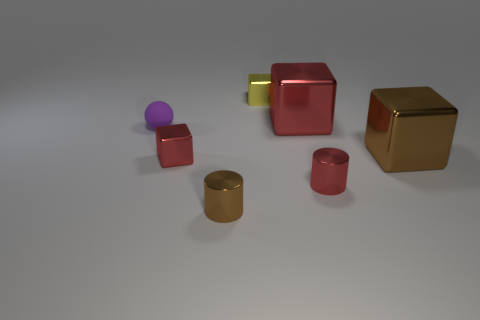Is there anything else that has the same material as the tiny purple ball?
Your answer should be compact. No. There is a red thing to the left of the yellow object; is it the same shape as the small matte thing?
Your answer should be very brief. No. There is a brown metallic thing in front of the brown block on the right side of the red metal cube that is behind the purple ball; what is its shape?
Give a very brief answer. Cylinder. The purple rubber ball is what size?
Make the answer very short. Small. The other tiny cylinder that is the same material as the red cylinder is what color?
Offer a terse response. Brown. How many brown cylinders are made of the same material as the small red cube?
Offer a very short reply. 1. Does the rubber thing have the same color as the small cylinder left of the small yellow metallic block?
Offer a terse response. No. The tiny object that is to the left of the tiny cube in front of the yellow cube is what color?
Offer a very short reply. Purple. There is a matte ball that is the same size as the brown cylinder; what is its color?
Provide a short and direct response. Purple. Are there any red shiny objects that have the same shape as the tiny purple rubber thing?
Your response must be concise. No. 